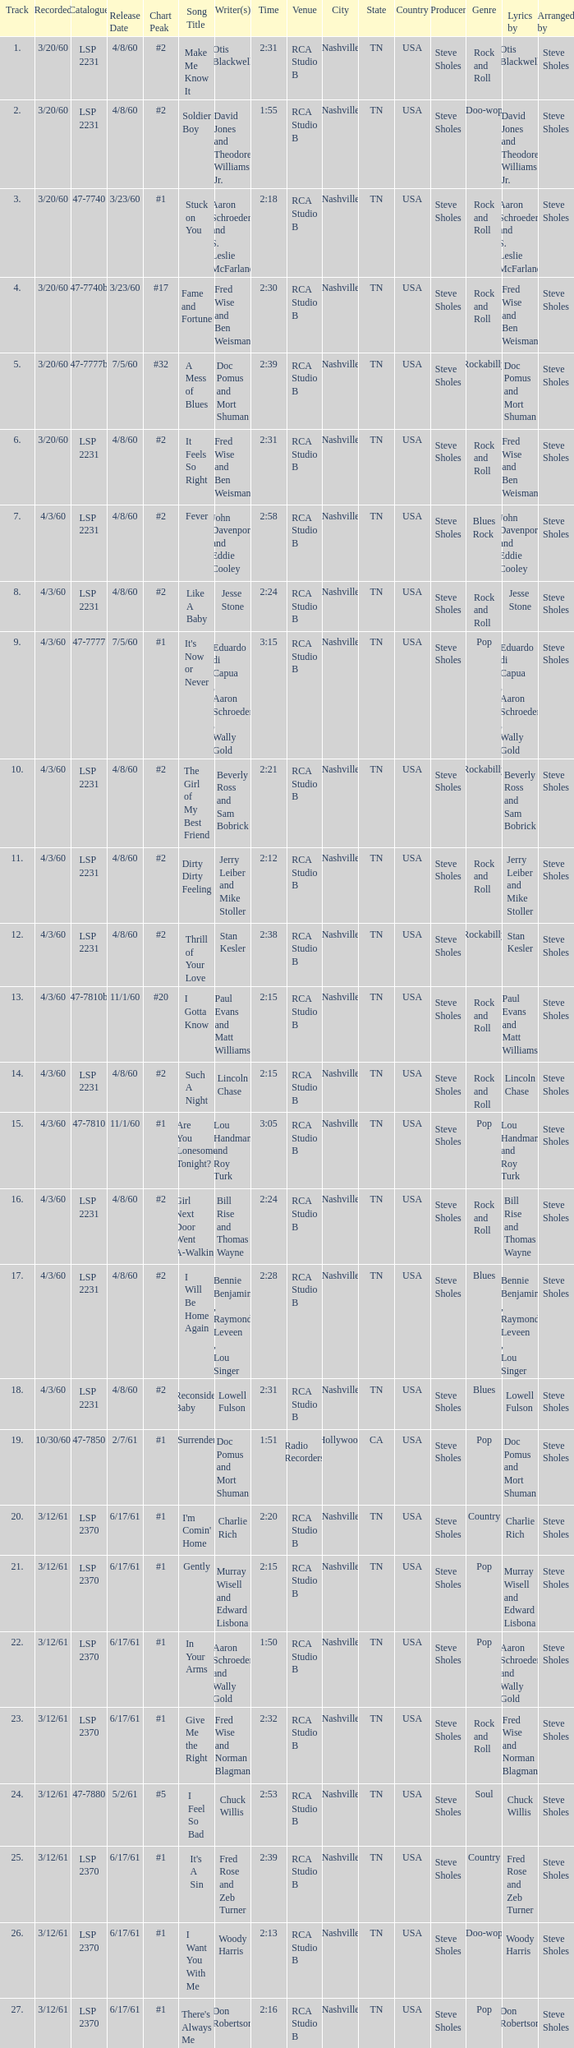What is the time of songs that have the writer Aaron Schroeder and Wally Gold? 1:50. 